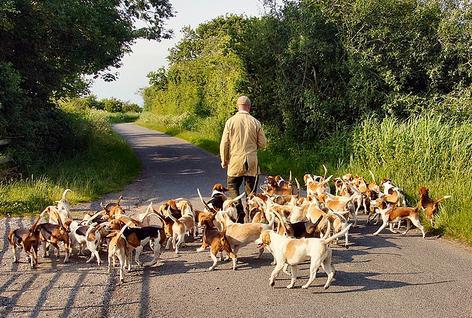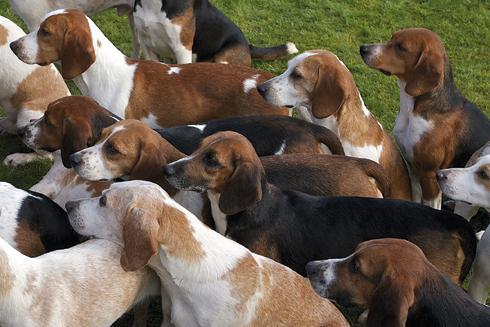The first image is the image on the left, the second image is the image on the right. For the images shown, is this caption "A bloody carcass lies in the grass in one image." true? Answer yes or no. No. 